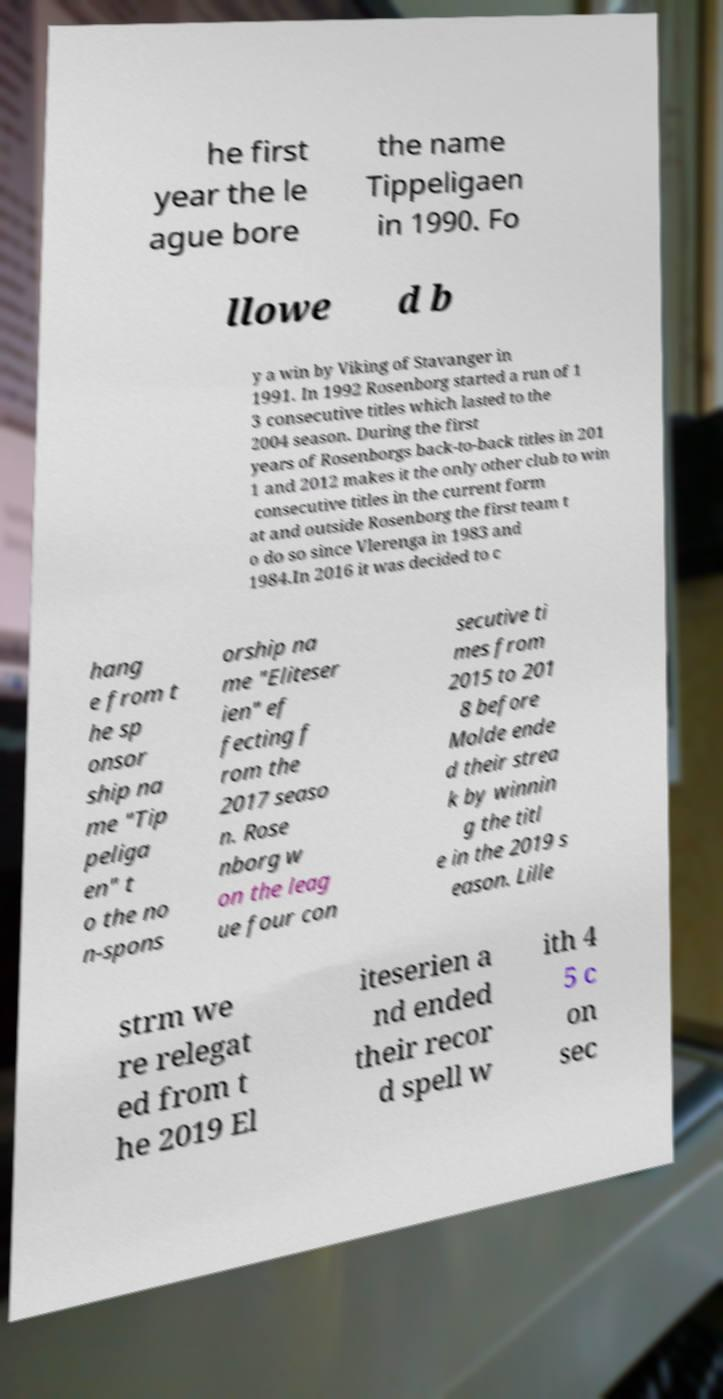Please identify and transcribe the text found in this image. he first year the le ague bore the name Tippeligaen in 1990. Fo llowe d b y a win by Viking of Stavanger in 1991. In 1992 Rosenborg started a run of 1 3 consecutive titles which lasted to the 2004 season. During the first years of Rosenborgs back-to-back titles in 201 1 and 2012 makes it the only other club to win consecutive titles in the current form at and outside Rosenborg the first team t o do so since Vlerenga in 1983 and 1984.In 2016 it was decided to c hang e from t he sp onsor ship na me "Tip peliga en" t o the no n-spons orship na me "Eliteser ien" ef fecting f rom the 2017 seaso n. Rose nborg w on the leag ue four con secutive ti mes from 2015 to 201 8 before Molde ende d their strea k by winnin g the titl e in the 2019 s eason. Lille strm we re relegat ed from t he 2019 El iteserien a nd ended their recor d spell w ith 4 5 c on sec 